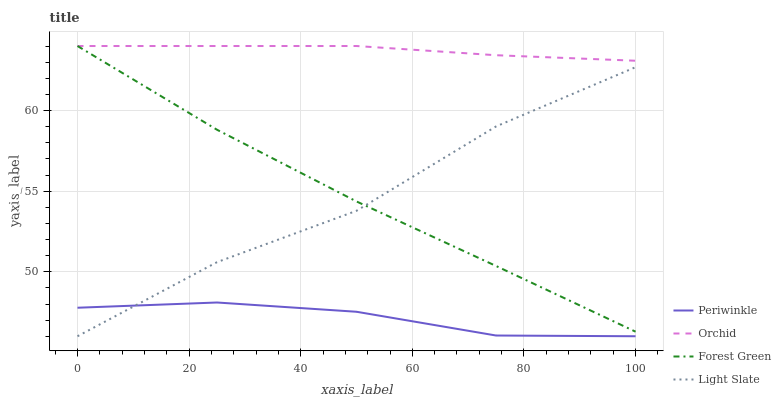Does Periwinkle have the minimum area under the curve?
Answer yes or no. Yes. Does Orchid have the maximum area under the curve?
Answer yes or no. Yes. Does Forest Green have the minimum area under the curve?
Answer yes or no. No. Does Forest Green have the maximum area under the curve?
Answer yes or no. No. Is Orchid the smoothest?
Answer yes or no. Yes. Is Light Slate the roughest?
Answer yes or no. Yes. Is Forest Green the smoothest?
Answer yes or no. No. Is Forest Green the roughest?
Answer yes or no. No. Does Light Slate have the lowest value?
Answer yes or no. Yes. Does Forest Green have the lowest value?
Answer yes or no. No. Does Orchid have the highest value?
Answer yes or no. Yes. Does Periwinkle have the highest value?
Answer yes or no. No. Is Light Slate less than Orchid?
Answer yes or no. Yes. Is Orchid greater than Light Slate?
Answer yes or no. Yes. Does Periwinkle intersect Light Slate?
Answer yes or no. Yes. Is Periwinkle less than Light Slate?
Answer yes or no. No. Is Periwinkle greater than Light Slate?
Answer yes or no. No. Does Light Slate intersect Orchid?
Answer yes or no. No. 